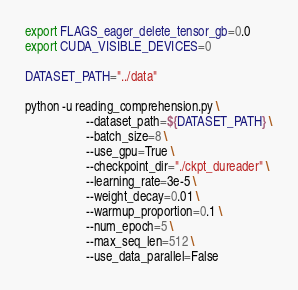<code> <loc_0><loc_0><loc_500><loc_500><_Bash_>export FLAGS_eager_delete_tensor_gb=0.0
export CUDA_VISIBLE_DEVICES=0

DATASET_PATH="../data"

python -u reading_comprehension.py \
                   --dataset_path=${DATASET_PATH} \
                   --batch_size=8 \
                   --use_gpu=True \
                   --checkpoint_dir="./ckpt_dureader" \
                   --learning_rate=3e-5 \
                   --weight_decay=0.01 \
                   --warmup_proportion=0.1 \
                   --num_epoch=5 \
                   --max_seq_len=512 \
                   --use_data_parallel=False

</code> 